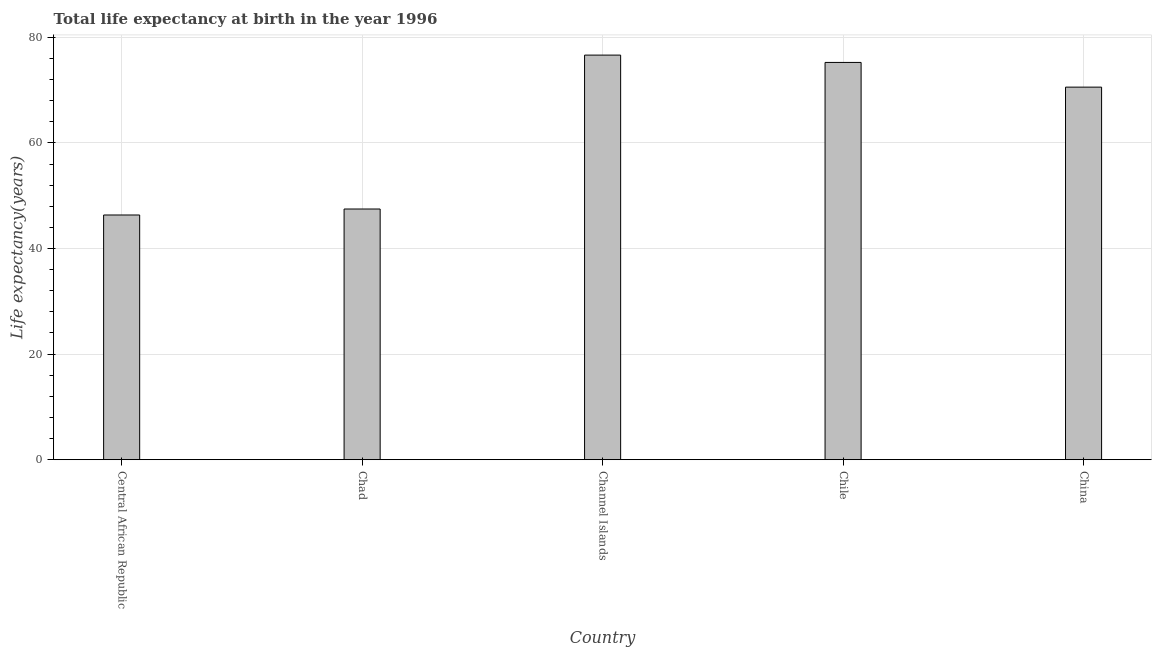Does the graph contain any zero values?
Offer a terse response. No. What is the title of the graph?
Make the answer very short. Total life expectancy at birth in the year 1996. What is the label or title of the X-axis?
Ensure brevity in your answer.  Country. What is the label or title of the Y-axis?
Your answer should be compact. Life expectancy(years). What is the life expectancy at birth in Chile?
Make the answer very short. 75.24. Across all countries, what is the maximum life expectancy at birth?
Provide a succinct answer. 76.63. Across all countries, what is the minimum life expectancy at birth?
Keep it short and to the point. 46.35. In which country was the life expectancy at birth maximum?
Make the answer very short. Channel Islands. In which country was the life expectancy at birth minimum?
Provide a succinct answer. Central African Republic. What is the sum of the life expectancy at birth?
Your response must be concise. 316.26. What is the difference between the life expectancy at birth in Chad and China?
Keep it short and to the point. -23.08. What is the average life expectancy at birth per country?
Keep it short and to the point. 63.25. What is the median life expectancy at birth?
Your response must be concise. 70.56. In how many countries, is the life expectancy at birth greater than 56 years?
Keep it short and to the point. 3. What is the ratio of the life expectancy at birth in Channel Islands to that in Chile?
Provide a short and direct response. 1.02. What is the difference between the highest and the second highest life expectancy at birth?
Offer a very short reply. 1.39. What is the difference between the highest and the lowest life expectancy at birth?
Offer a terse response. 30.28. In how many countries, is the life expectancy at birth greater than the average life expectancy at birth taken over all countries?
Give a very brief answer. 3. How many bars are there?
Ensure brevity in your answer.  5. What is the difference between two consecutive major ticks on the Y-axis?
Your answer should be very brief. 20. What is the Life expectancy(years) in Central African Republic?
Your response must be concise. 46.35. What is the Life expectancy(years) of Chad?
Provide a short and direct response. 47.48. What is the Life expectancy(years) of Channel Islands?
Your response must be concise. 76.63. What is the Life expectancy(years) of Chile?
Give a very brief answer. 75.24. What is the Life expectancy(years) of China?
Ensure brevity in your answer.  70.56. What is the difference between the Life expectancy(years) in Central African Republic and Chad?
Make the answer very short. -1.14. What is the difference between the Life expectancy(years) in Central African Republic and Channel Islands?
Make the answer very short. -30.28. What is the difference between the Life expectancy(years) in Central African Republic and Chile?
Your answer should be very brief. -28.9. What is the difference between the Life expectancy(years) in Central African Republic and China?
Give a very brief answer. -24.22. What is the difference between the Life expectancy(years) in Chad and Channel Islands?
Make the answer very short. -29.15. What is the difference between the Life expectancy(years) in Chad and Chile?
Your answer should be compact. -27.76. What is the difference between the Life expectancy(years) in Chad and China?
Offer a terse response. -23.08. What is the difference between the Life expectancy(years) in Channel Islands and Chile?
Provide a succinct answer. 1.39. What is the difference between the Life expectancy(years) in Channel Islands and China?
Keep it short and to the point. 6.07. What is the difference between the Life expectancy(years) in Chile and China?
Give a very brief answer. 4.68. What is the ratio of the Life expectancy(years) in Central African Republic to that in Chad?
Provide a short and direct response. 0.98. What is the ratio of the Life expectancy(years) in Central African Republic to that in Channel Islands?
Your response must be concise. 0.6. What is the ratio of the Life expectancy(years) in Central African Republic to that in Chile?
Make the answer very short. 0.62. What is the ratio of the Life expectancy(years) in Central African Republic to that in China?
Give a very brief answer. 0.66. What is the ratio of the Life expectancy(years) in Chad to that in Channel Islands?
Give a very brief answer. 0.62. What is the ratio of the Life expectancy(years) in Chad to that in Chile?
Give a very brief answer. 0.63. What is the ratio of the Life expectancy(years) in Chad to that in China?
Your answer should be compact. 0.67. What is the ratio of the Life expectancy(years) in Channel Islands to that in Chile?
Ensure brevity in your answer.  1.02. What is the ratio of the Life expectancy(years) in Channel Islands to that in China?
Offer a very short reply. 1.09. What is the ratio of the Life expectancy(years) in Chile to that in China?
Give a very brief answer. 1.07. 